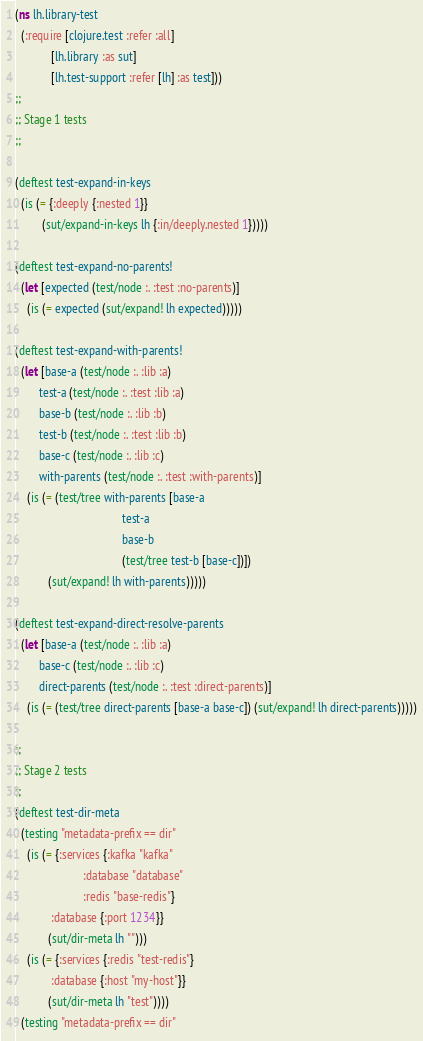<code> <loc_0><loc_0><loc_500><loc_500><_Clojure_>(ns lh.library-test
  (:require [clojure.test :refer :all]
            [lh.library :as sut]
            [lh.test-support :refer [lh] :as test]))
;;
;; Stage 1 tests
;;

(deftest test-expand-in-keys
  (is (= {:deeply {:nested 1}}
         (sut/expand-in-keys lh {:in/deeply.nested 1}))))

(deftest test-expand-no-parents!
  (let [expected (test/node :. :test :no-parents)]
    (is (= expected (sut/expand! lh expected)))))

(deftest test-expand-with-parents!
  (let [base-a (test/node :. :lib :a)
        test-a (test/node :. :test :lib :a)
        base-b (test/node :. :lib :b)
        test-b (test/node :. :test :lib :b)
        base-c (test/node :. :lib :c)
        with-parents (test/node :. :test :with-parents)]
    (is (= (test/tree with-parents [base-a
                                    test-a
                                    base-b
                                    (test/tree test-b [base-c])])
           (sut/expand! lh with-parents)))))

(deftest test-expand-direct-resolve-parents
  (let [base-a (test/node :. :lib :a)
        base-c (test/node :. :lib :c)
        direct-parents (test/node :. :test :direct-parents)]
    (is (= (test/tree direct-parents [base-a base-c]) (sut/expand! lh direct-parents)))))

;;
;; Stage 2 tests
;;
(deftest test-dir-meta
  (testing "metadata-prefix == dir"
    (is (= {:services {:kafka "kafka"
                       :database "database"
                       :redis "base-redis"}
            :database {:port 1234}}
           (sut/dir-meta lh "")))
    (is (= {:services {:redis "test-redis"}
            :database {:host "my-host"}}
           (sut/dir-meta lh "test"))))
  (testing "metadata-prefix == dir"</code> 